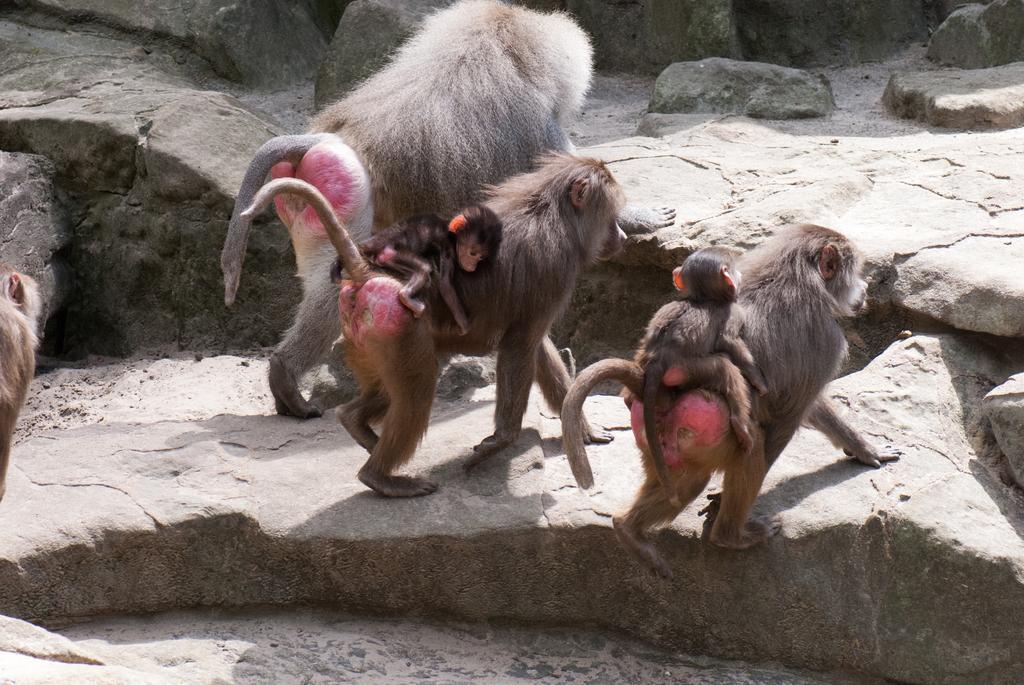Please provide a concise description of this image. This is the picture of some monkeys, among them two are carrying some baby monkeys on them and they are on the rock floor. 